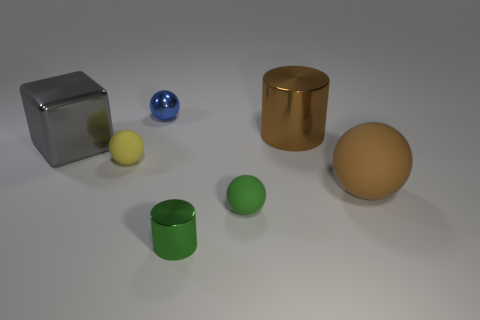Is the number of shiny cylinders on the left side of the tiny green metal object greater than the number of big gray metal blocks behind the gray thing?
Your response must be concise. No. What number of other objects are the same shape as the gray object?
Provide a succinct answer. 0. There is a tiny metal object on the right side of the tiny metal ball; are there any tiny green balls that are right of it?
Give a very brief answer. Yes. What number of big cylinders are there?
Your answer should be very brief. 1. Do the big metal cylinder and the small metallic object that is in front of the brown rubber thing have the same color?
Make the answer very short. No. Is the number of metallic blocks greater than the number of small yellow metal cylinders?
Your answer should be compact. Yes. Is there any other thing of the same color as the metal block?
Your answer should be compact. No. What number of other objects are the same size as the gray block?
Ensure brevity in your answer.  2. The small thing that is in front of the tiny rubber sphere that is right of the blue object that is behind the small yellow sphere is made of what material?
Your answer should be compact. Metal. Is the cube made of the same material as the big object on the right side of the large brown shiny cylinder?
Offer a very short reply. No. 